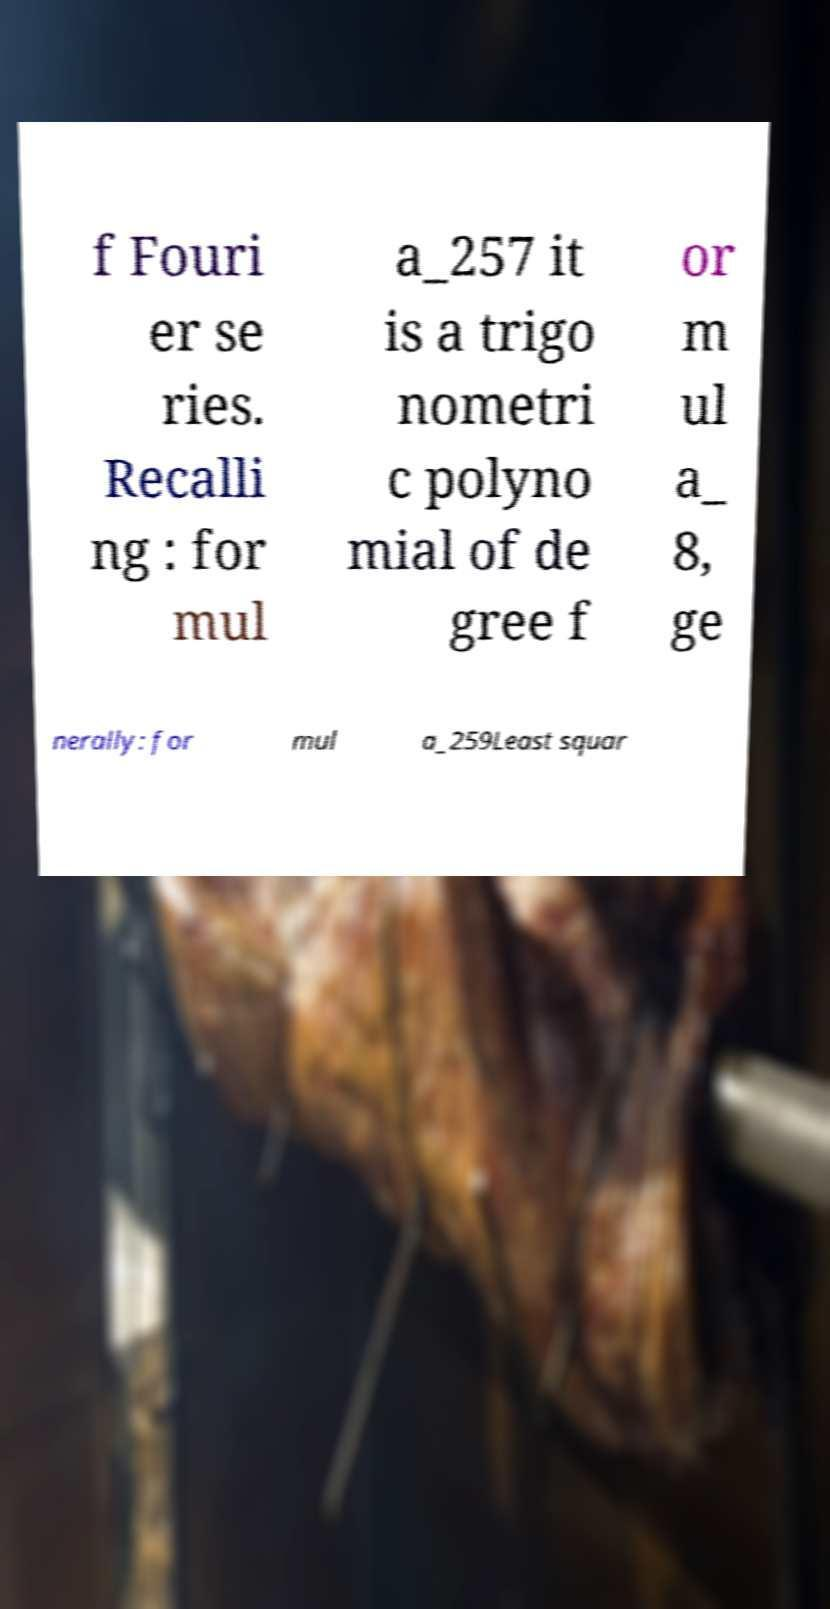There's text embedded in this image that I need extracted. Can you transcribe it verbatim? f Fouri er se ries. Recalli ng : for mul a_257 it is a trigo nometri c polyno mial of de gree f or m ul a_ 8, ge nerally: for mul a_259Least squar 